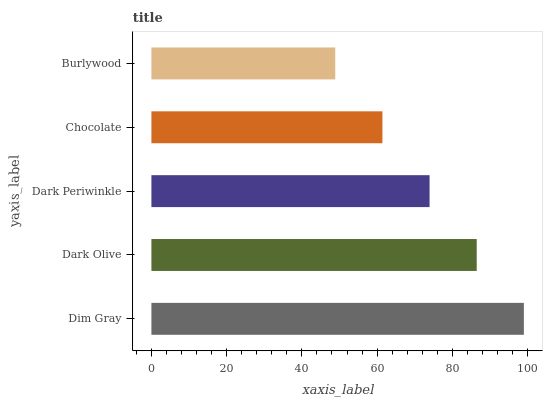Is Burlywood the minimum?
Answer yes or no. Yes. Is Dim Gray the maximum?
Answer yes or no. Yes. Is Dark Olive the minimum?
Answer yes or no. No. Is Dark Olive the maximum?
Answer yes or no. No. Is Dim Gray greater than Dark Olive?
Answer yes or no. Yes. Is Dark Olive less than Dim Gray?
Answer yes or no. Yes. Is Dark Olive greater than Dim Gray?
Answer yes or no. No. Is Dim Gray less than Dark Olive?
Answer yes or no. No. Is Dark Periwinkle the high median?
Answer yes or no. Yes. Is Dark Periwinkle the low median?
Answer yes or no. Yes. Is Chocolate the high median?
Answer yes or no. No. Is Burlywood the low median?
Answer yes or no. No. 